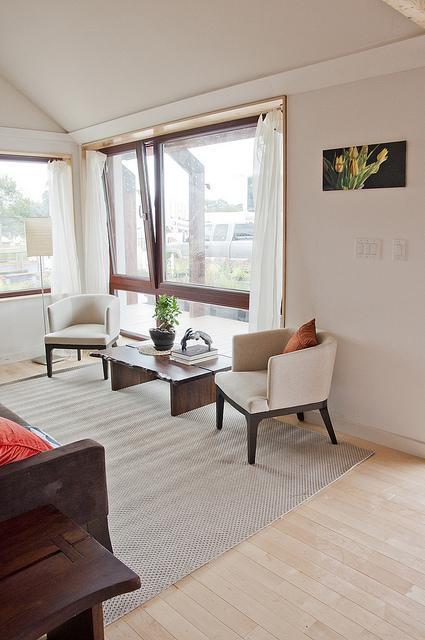How many tables are in the room?
Give a very brief answer. 1. How many chairs are there?
Give a very brief answer. 2. How many birds are in this picture?
Give a very brief answer. 0. 